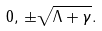Convert formula to latex. <formula><loc_0><loc_0><loc_500><loc_500>0 , \, \pm \sqrt { \Lambda + \gamma } .</formula> 